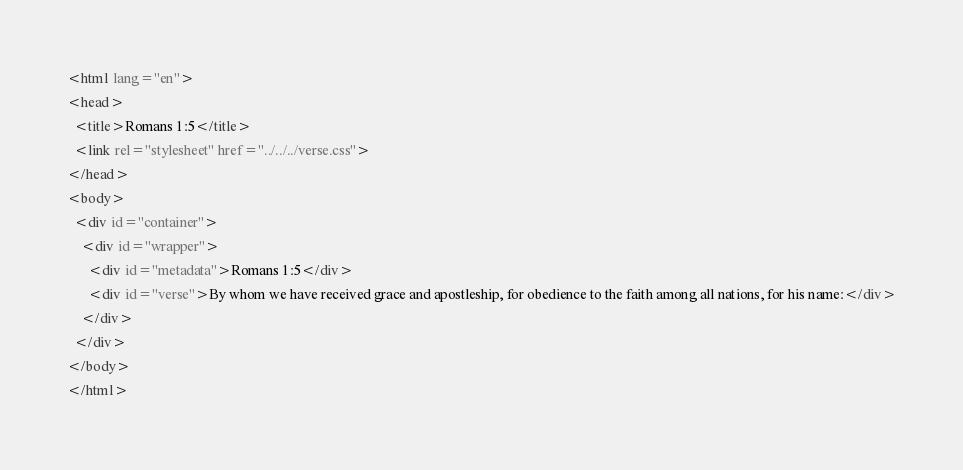<code> <loc_0><loc_0><loc_500><loc_500><_HTML_><html lang="en">
<head>
  <title>Romans 1:5</title>
  <link rel="stylesheet" href="../../../verse.css">
</head>
<body>
  <div id="container">
    <div id="wrapper">
      <div id="metadata">Romans 1:5</div>
      <div id="verse">By whom we have received grace and apostleship, for obedience to the faith among all nations, for his name:</div>
    </div>
  </div>
</body>
</html></code> 